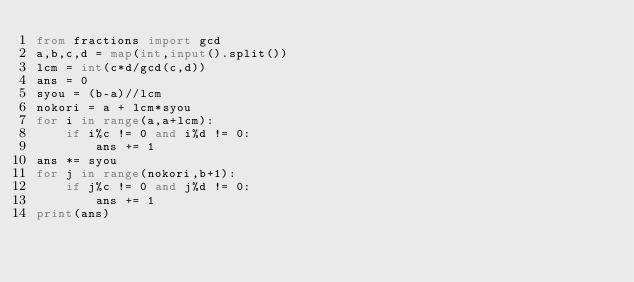Convert code to text. <code><loc_0><loc_0><loc_500><loc_500><_Python_>from fractions import gcd
a,b,c,d = map(int,input().split())
lcm = int(c*d/gcd(c,d))
ans = 0
syou = (b-a)//lcm
nokori = a + lcm*syou
for i in range(a,a+lcm):
    if i%c != 0 and i%d != 0:
        ans += 1
ans *= syou
for j in range(nokori,b+1):
    if j%c != 0 and j%d != 0:
        ans += 1
print(ans)</code> 